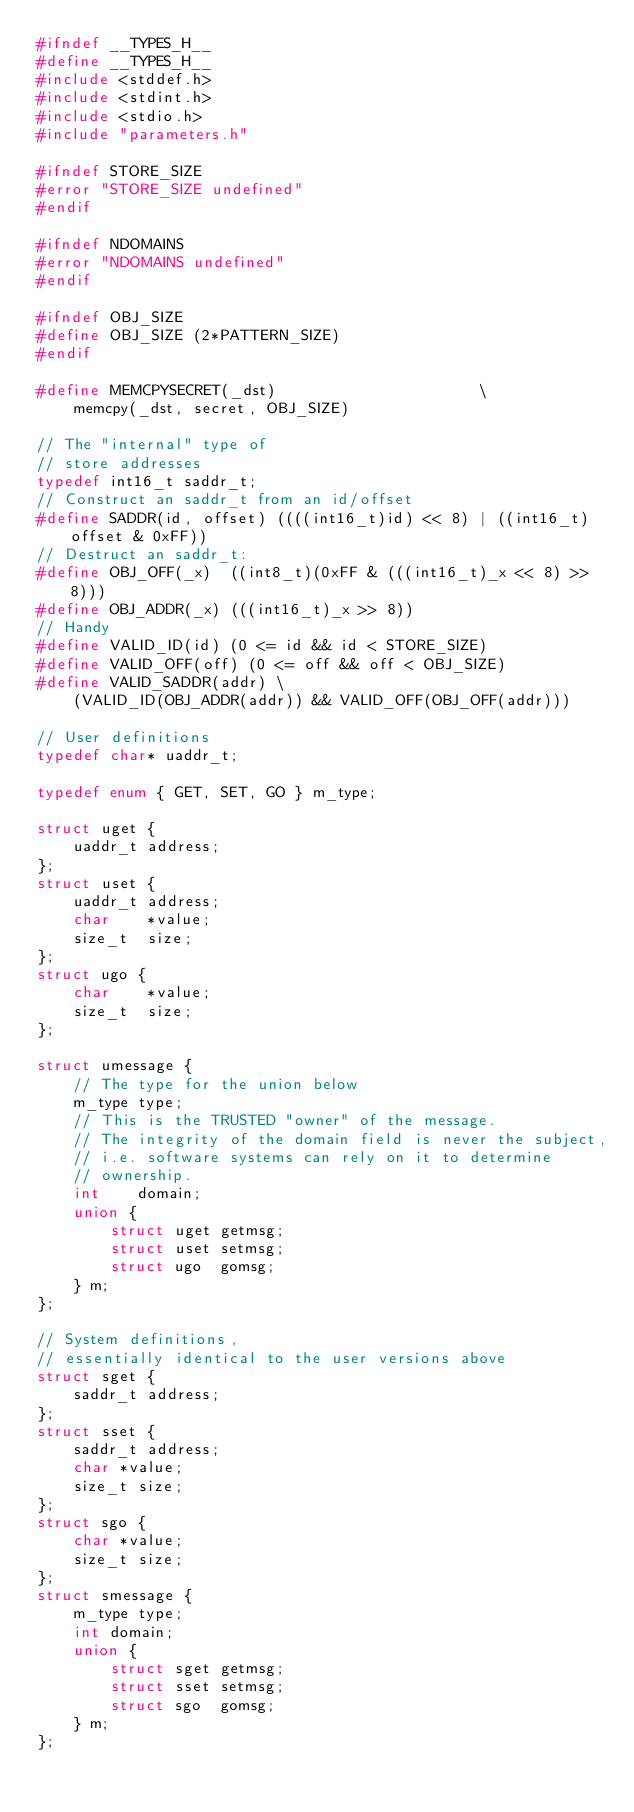<code> <loc_0><loc_0><loc_500><loc_500><_C_>#ifndef __TYPES_H__
#define __TYPES_H__
#include <stddef.h>
#include <stdint.h>
#include <stdio.h>
#include "parameters.h"

#ifndef STORE_SIZE
#error "STORE_SIZE undefined"
#endif

#ifndef NDOMAINS
#error "NDOMAINS undefined"
#endif

#ifndef OBJ_SIZE
#define OBJ_SIZE (2*PATTERN_SIZE)
#endif

#define MEMCPYSECRET(_dst)                      \
    memcpy(_dst, secret, OBJ_SIZE)

// The "internal" type of
// store addresses
typedef int16_t saddr_t;
// Construct an saddr_t from an id/offset
#define SADDR(id, offset) ((((int16_t)id) << 8) | ((int16_t)offset & 0xFF))
// Destruct an saddr_t:
#define OBJ_OFF(_x)  ((int8_t)(0xFF & (((int16_t)_x << 8) >> 8)))
#define OBJ_ADDR(_x) (((int16_t)_x >> 8))
// Handy
#define VALID_ID(id) (0 <= id && id < STORE_SIZE)
#define VALID_OFF(off) (0 <= off && off < OBJ_SIZE)
#define VALID_SADDR(addr) \
    (VALID_ID(OBJ_ADDR(addr)) && VALID_OFF(OBJ_OFF(addr)))

// User definitions
typedef char* uaddr_t;

typedef enum { GET, SET, GO } m_type;

struct uget {
    uaddr_t address;
};
struct uset {
    uaddr_t address;
    char    *value;
    size_t  size;
};
struct ugo {
    char    *value;
    size_t  size;
};

struct umessage {
    // The type for the union below
    m_type type;
    // This is the TRUSTED "owner" of the message.
    // The integrity of the domain field is never the subject,
    // i.e. software systems can rely on it to determine
    // ownership.
    int    domain;
    union {
        struct uget getmsg;
        struct uset setmsg;
        struct ugo  gomsg;
    } m;
};

// System definitions,
// essentially identical to the user versions above
struct sget {
    saddr_t address;
};
struct sset {
    saddr_t address;
    char *value;
    size_t size;
};
struct sgo {
    char *value;
    size_t size;
};
struct smessage {
    m_type type;
    int domain;
    union {
        struct sget getmsg;
        struct sset setmsg;
        struct sgo  gomsg;
    } m;
};
</code> 